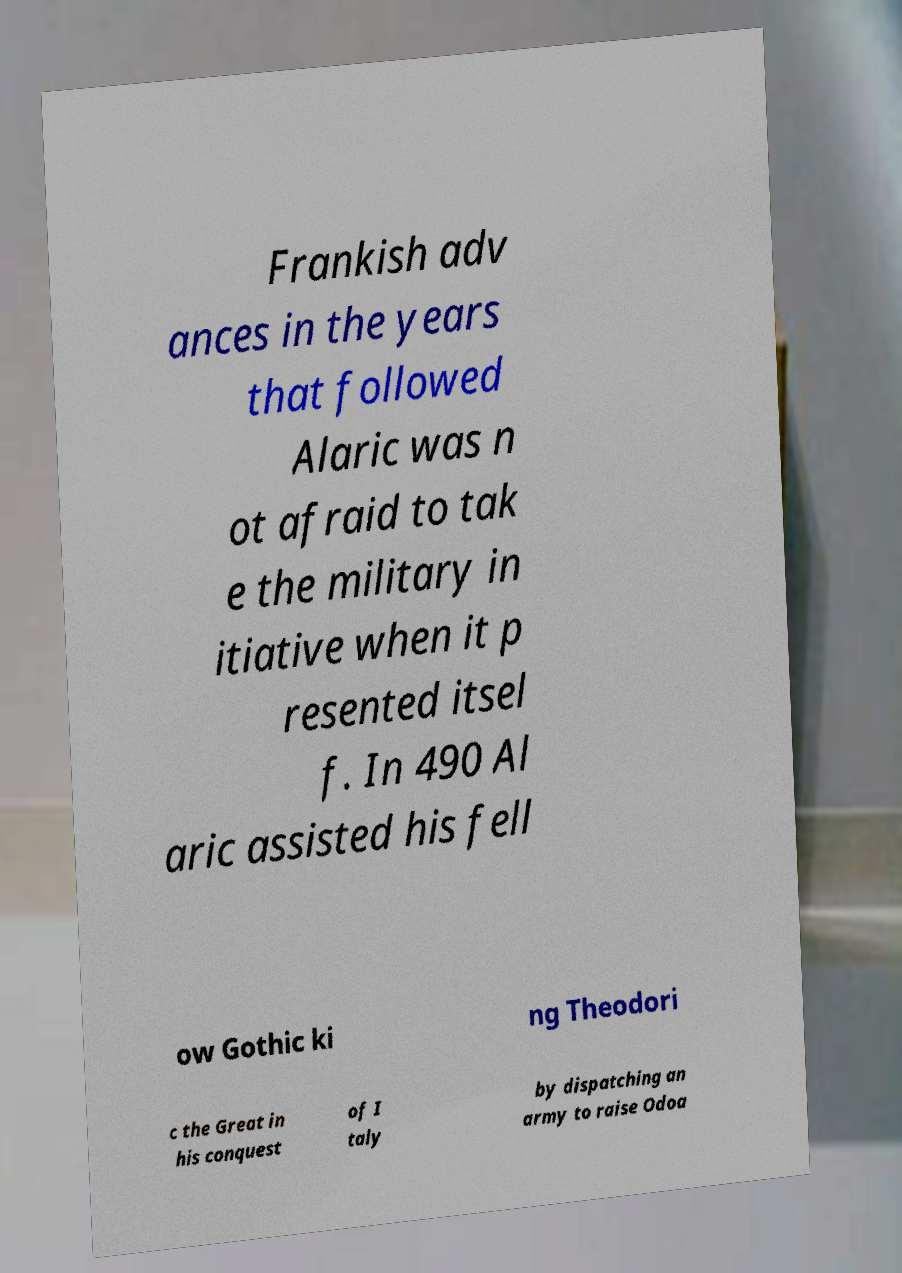Please read and relay the text visible in this image. What does it say? Frankish adv ances in the years that followed Alaric was n ot afraid to tak e the military in itiative when it p resented itsel f. In 490 Al aric assisted his fell ow Gothic ki ng Theodori c the Great in his conquest of I taly by dispatching an army to raise Odoa 